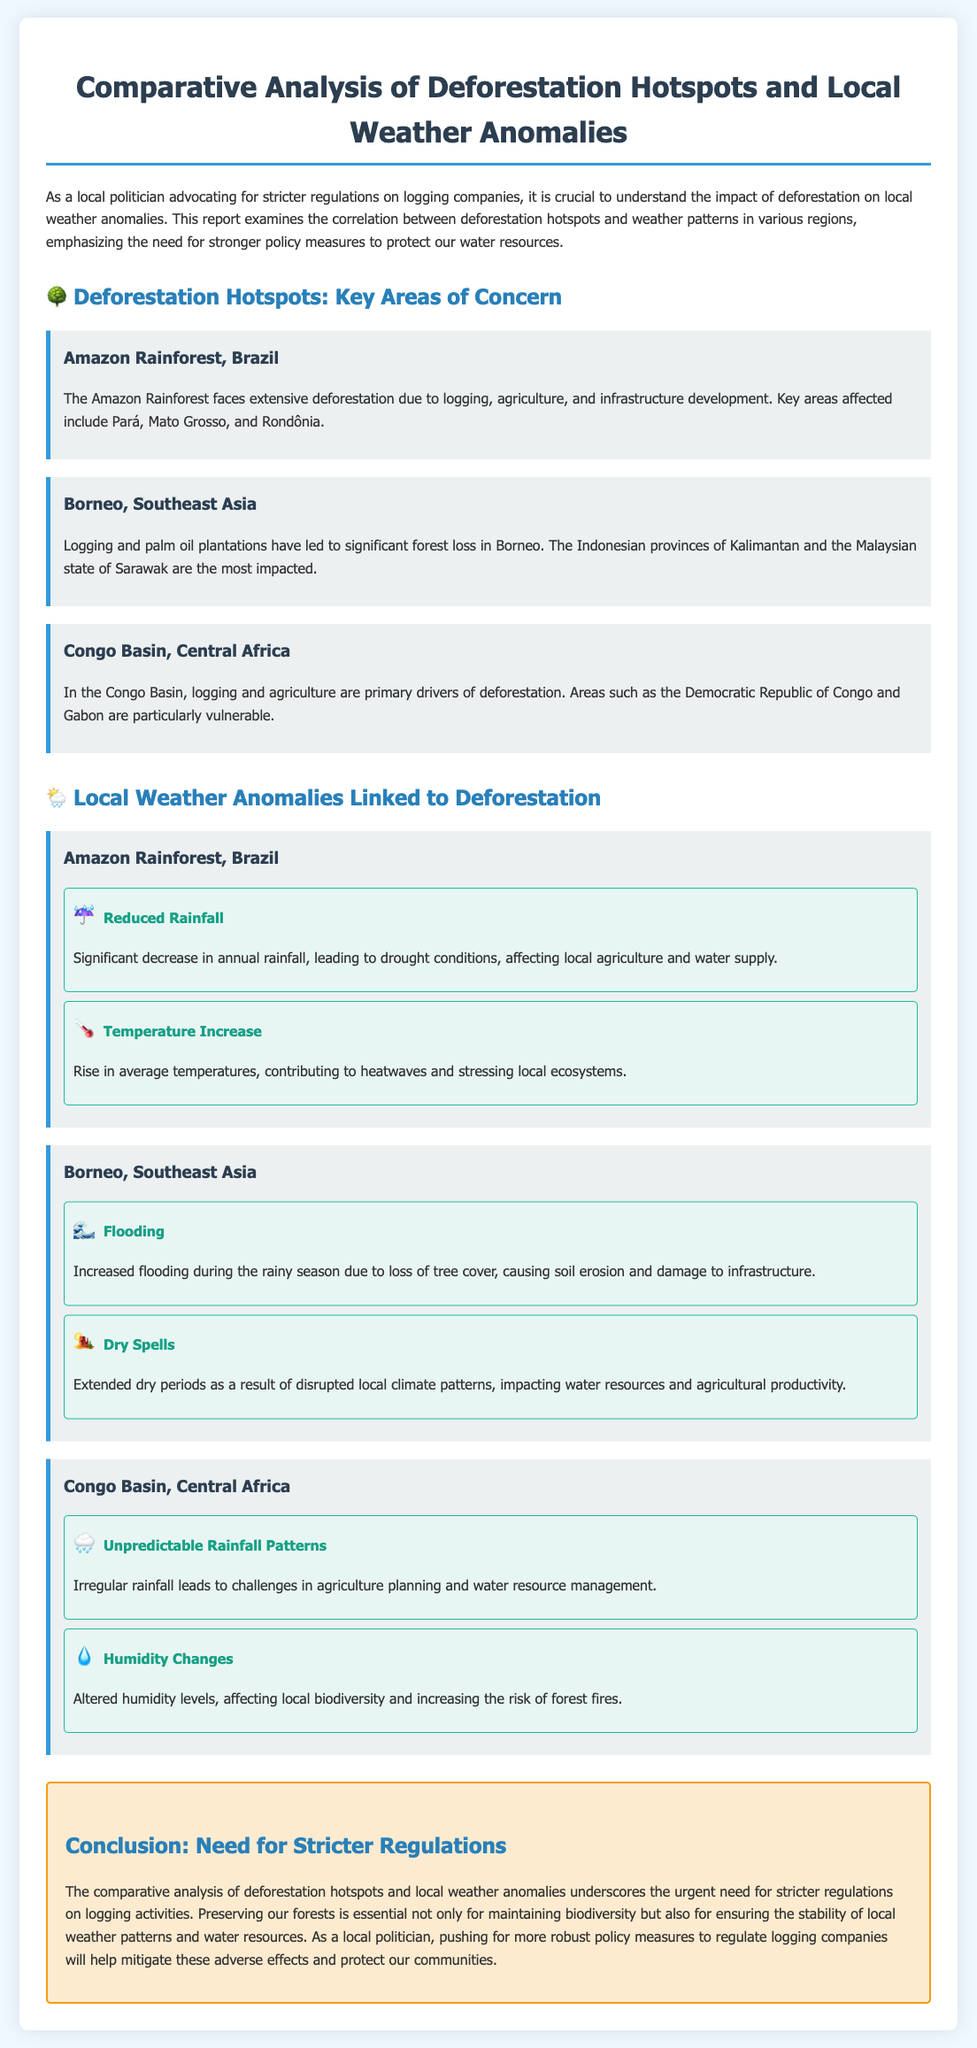What are the three deforestation hotspots mentioned? The hotspots mentioned are the Amazon Rainforest, Borneo, and the Congo Basin.
Answer: Amazon Rainforest, Borneo, Congo Basin Which area faces reduced rainfall as a local weather anomaly? The Amazon Rainforest experiences reduced rainfall, leading to drought conditions.
Answer: Amazon Rainforest What percentage of the rainfall has significantly decreased in the Amazon? The document does not specify a percentage for the decrease in rainfall.
Answer: Not specified What is the primary driver of deforestation in the Congo Basin? The primary driver of deforestation in the Congo Basin is logging and agriculture.
Answer: Logging and agriculture What notable weather anomaly is reported for Borneo? Increased flooding during the rainy season is noted as a significant weather anomaly in Borneo.
Answer: Increased flooding What can be concluded from the comparative analysis regarding logging regulations? The analysis underscores the urgent need for stricter regulations on logging activities to protect water resources.
Answer: Stricter regulations How do deforestation activities impact local temperature in the Amazon? Deforestation contributes to a rise in average temperatures, leading to heatwaves.
Answer: Rise in average temperatures What are the consequences of unpredictable rainfall patterns in the Congo Basin? Unpredictable rainfall leads to challenges in agriculture planning and water resource management.
Answer: Challenges in agriculture planning What does preserving forests help maintain? Preserving forests is essential for maintaining biodiversity and the stability of local weather patterns.
Answer: Biodiversity and stability of local weather patterns 